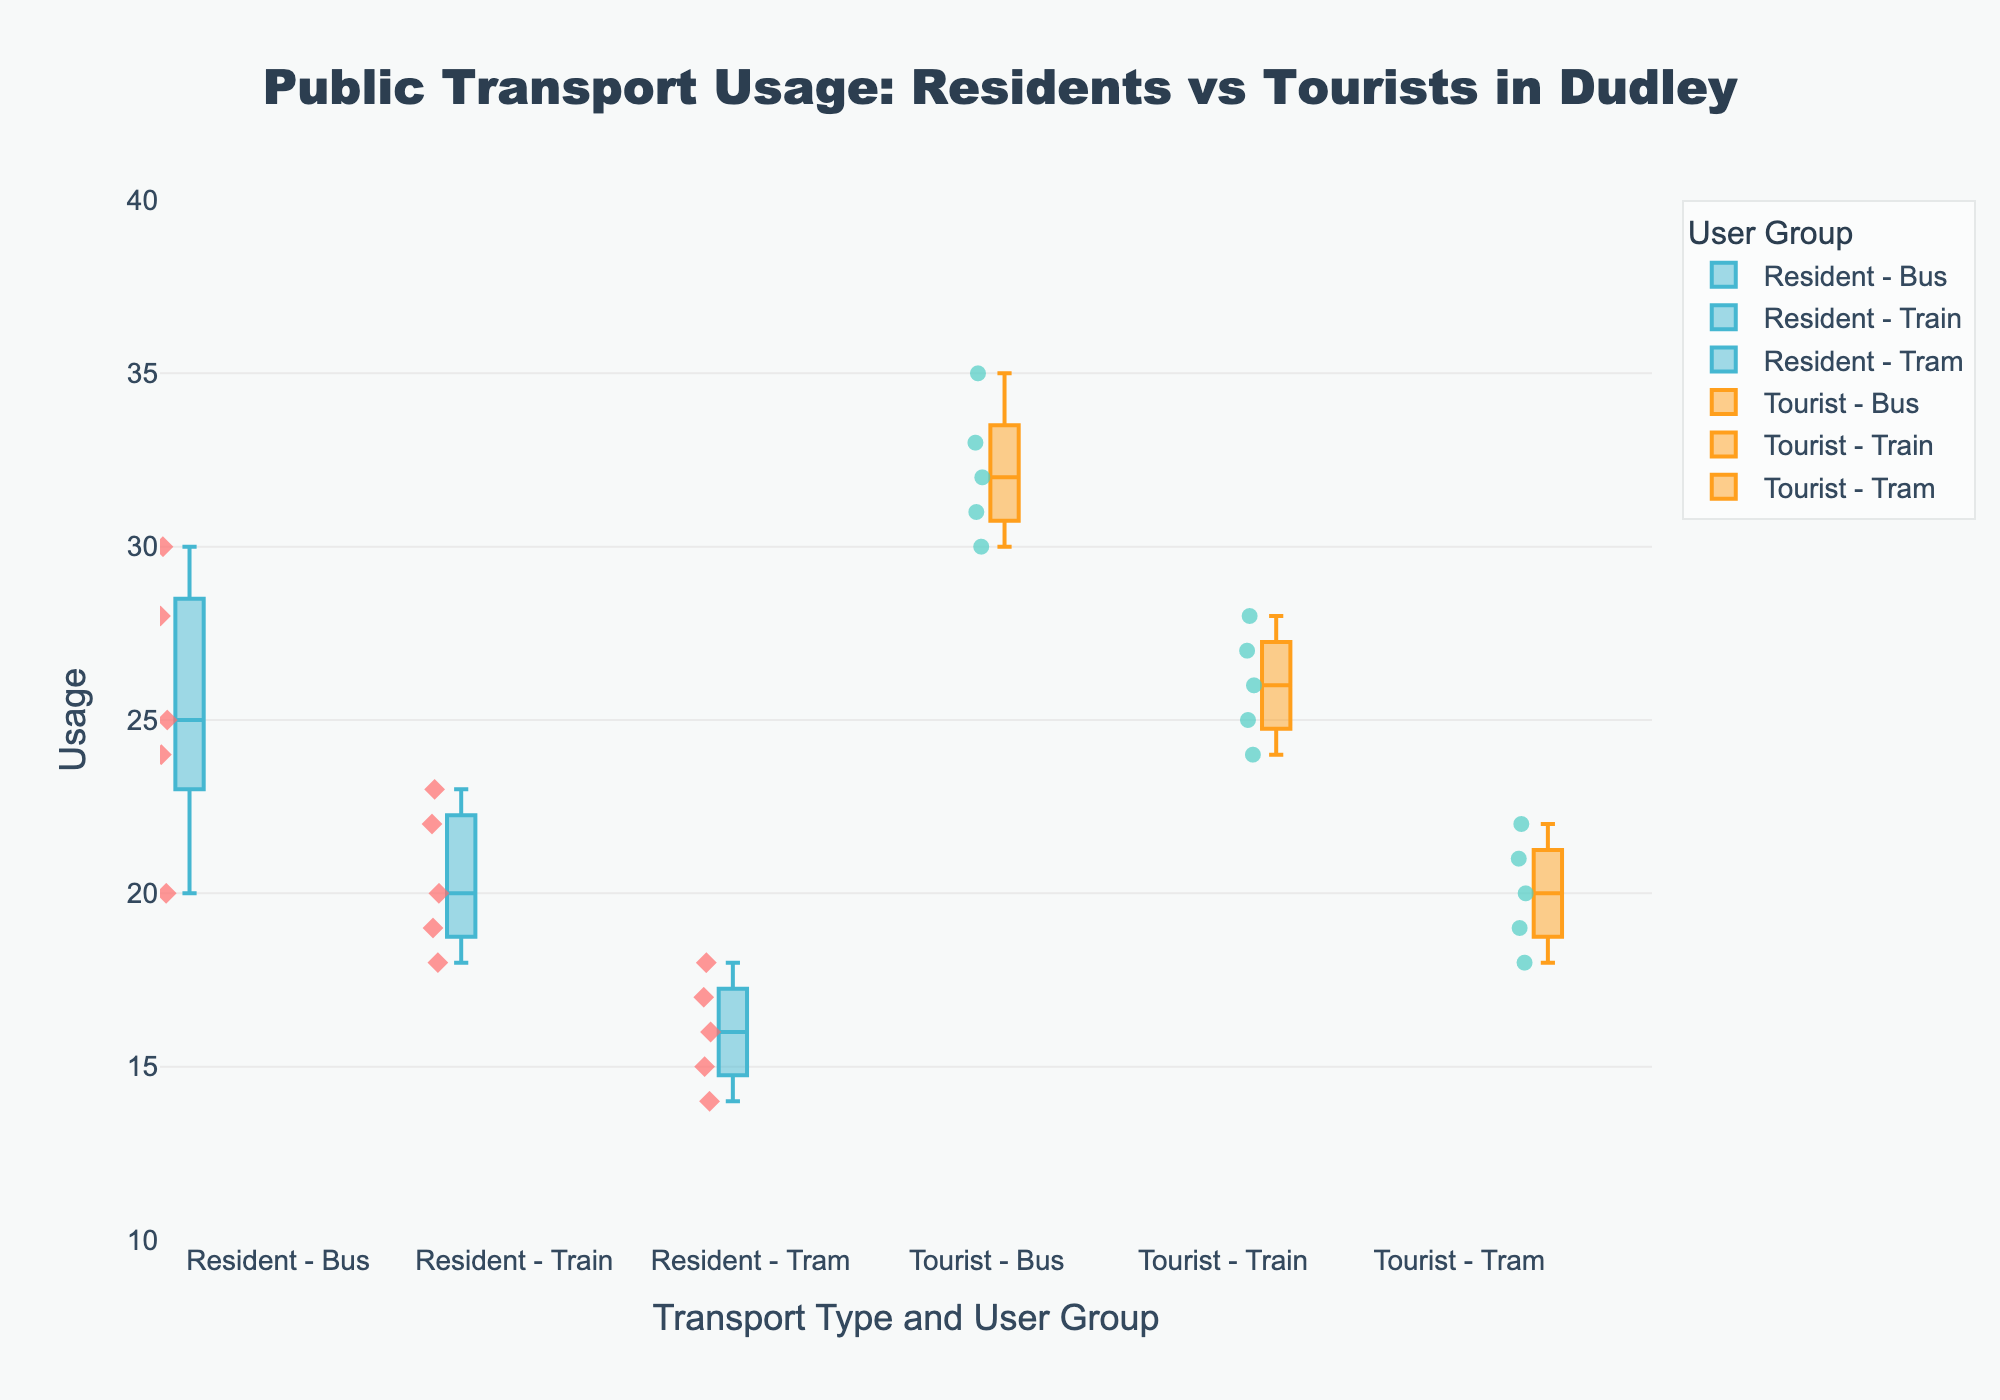Is the title of the plot about public transport usage in Dudley? The title states "Public Transport Usage: Residents vs Tourists in Dudley." This indicates that the plot deals with comparing public transport usage between residents and tourists in Dudley.
Answer: Yes Which group shows the highest median usage for trains? To find the highest median usage for trains, we look at the boxes corresponding to the train usage for both residents and tourists. The median is the line inside the box. Tourists have a higher median usage for trains.
Answer: Tourists What is the range of public transport usage values among residents using buses? The range is the difference between the highest and lowest values. From the plot, the highest value is 30 and the lowest is 20. Subtracting these gives 30 - 20.
Answer: 10 Whose tram usage has a higher variance, residents or tourists? Variance can be visually approximated by looking at the spread of data points and the length of the box for each group. Residents have more spread out data points and a longer box for tram usage compared to tourists, indicating higher variance.
Answer: Residents What is the median usage of buses by tourists? The median usage can be identified by the line in the center of the box representing tourists using buses. This median value, visually, is around the 31-32 mark.
Answer: 32 How does the highest usage value for tourists using trams compare to the highest usage value for residents using trams? Look at the top whiskers for both groups on tram usage. The highest value for tourists is 22, whereas for residents it is 18. So, tourists have a higher usage value.
Answer: Tourists' highest usage is higher What is the interquartile range (IQR) for residents' bus usage? The IQR is calculated by subtracting the 25th percentile (bottom line of the box) from the 75th percentile (top line of the box). These values appear to be 23 and 28, respectively. Thus, the IQR is 28 - 23.
Answer: 5 From the data, whose average usage of buses is higher, residents or tourists? To determine the average, add up all the respective usage values and divide by the number of data points. For residents: (25+30+20+24+28)/5 = 25.4. For tourists: (35+33+30+32+31)/5 = 32.2. Therefore, tourists have a higher average usage.
Answer: Tourists Which mode of transport shows the least variance in usage among tourists? Least variance can be visually determined by observing the smallest range within the boxplot. Among the options, trains for tourists show the least variance, as the box and whiskers are shortest for that transport compared to buses and trams.
Answer: Train 